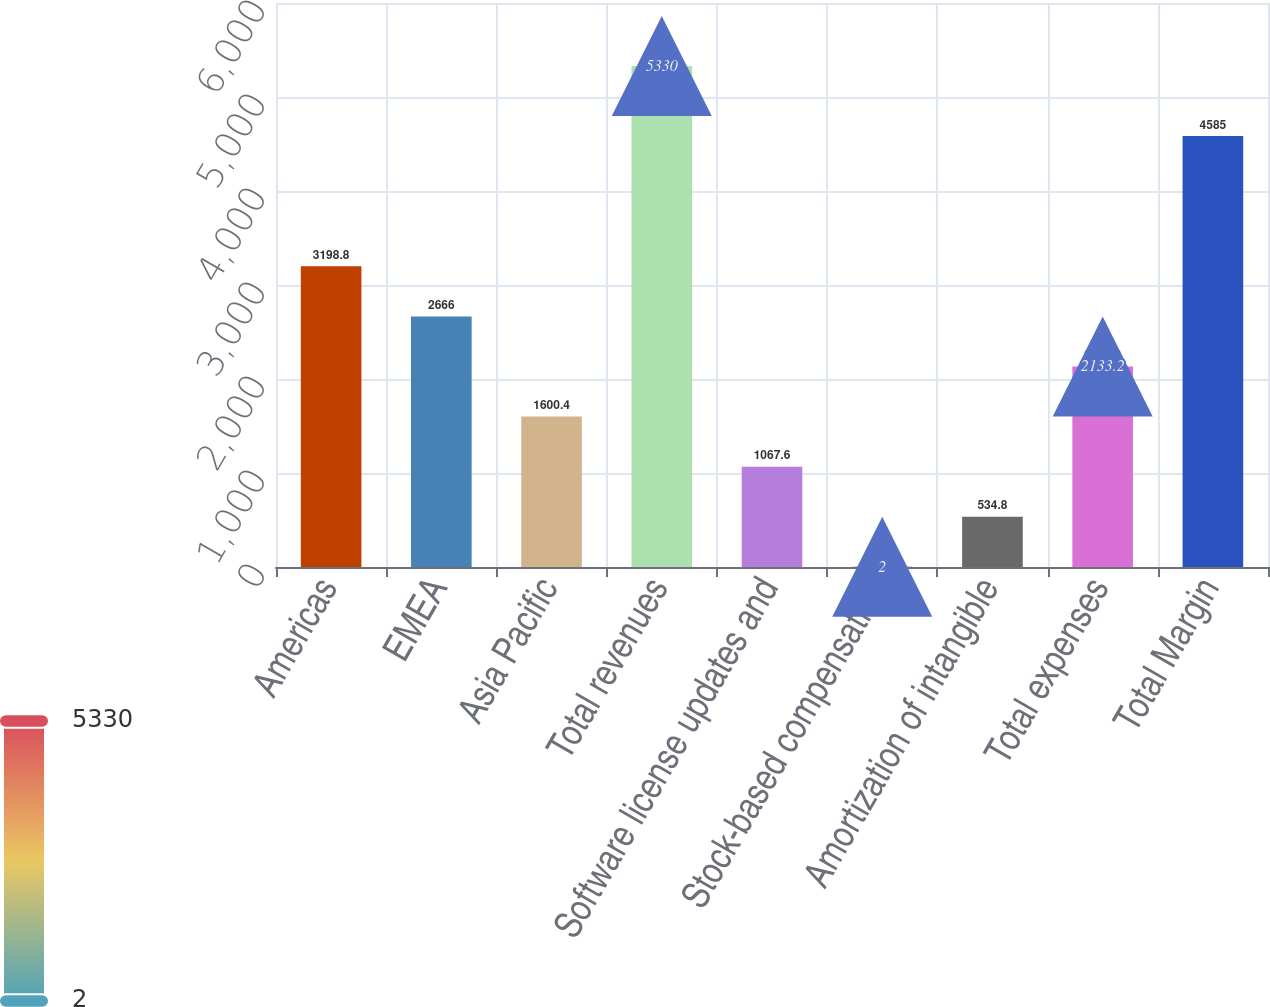Convert chart. <chart><loc_0><loc_0><loc_500><loc_500><bar_chart><fcel>Americas<fcel>EMEA<fcel>Asia Pacific<fcel>Total revenues<fcel>Software license updates and<fcel>Stock-based compensation<fcel>Amortization of intangible<fcel>Total expenses<fcel>Total Margin<nl><fcel>3198.8<fcel>2666<fcel>1600.4<fcel>5330<fcel>1067.6<fcel>2<fcel>534.8<fcel>2133.2<fcel>4585<nl></chart> 